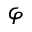<formula> <loc_0><loc_0><loc_500><loc_500>\varphi</formula> 